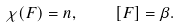<formula> <loc_0><loc_0><loc_500><loc_500>\chi ( F ) = n , \quad [ F ] = \beta .</formula> 